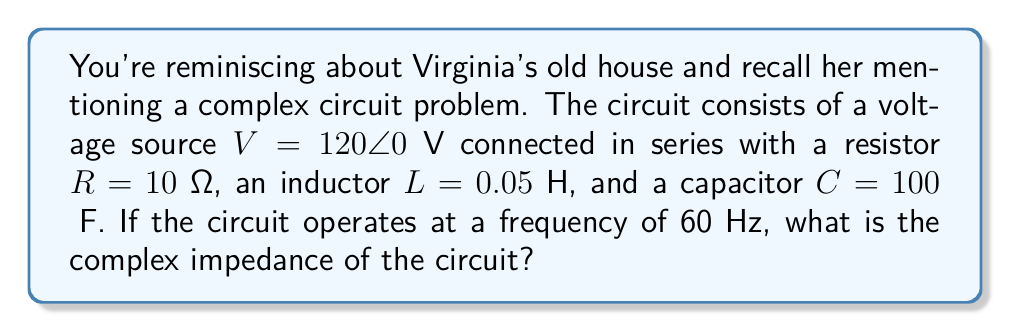What is the answer to this math problem? To solve this problem, we'll follow these steps:

1) Calculate the inductive reactance:
   $X_L = 2\pi fL$
   $X_L = 2\pi (60)(0.05) = 18.85$ Ω

2) Calculate the capacitive reactance:
   $X_C = \frac{1}{2\pi fC}$
   $X_C = \frac{1}{2\pi (60)(100 \times 10^{-6})} = 26.53$ Ω

3) Express the impedances in complex form:
   $Z_R = 10 + j0$ Ω
   $Z_L = 0 + j18.85$ Ω
   $Z_C = 0 - j26.53$ Ω

4) Sum the impedances:
   $Z_{total} = Z_R + Z_L + Z_C$
   $Z_{total} = (10 + j0) + (0 + j18.85) + (0 - j26.53)$
   $Z_{total} = 10 + j(18.85 - 26.53)$
   $Z_{total} = 10 - j7.68$ Ω

5) Convert to polar form:
   $|Z| = \sqrt{10^2 + (-7.68)^2} = 12.62$ Ω
   $\theta = \tan^{-1}(\frac{-7.68}{10}) = -37.52°$

Therefore, the complex impedance in polar form is $12.62\angle -37.52°$ Ω.
Answer: $12.62\angle -37.52°$ Ω 